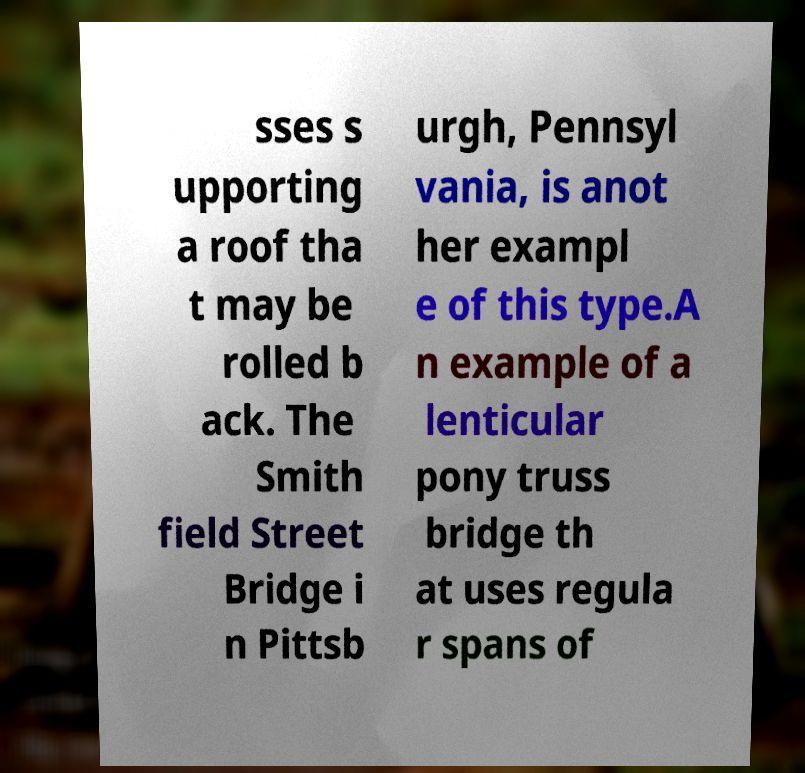Can you read and provide the text displayed in the image?This photo seems to have some interesting text. Can you extract and type it out for me? sses s upporting a roof tha t may be rolled b ack. The Smith field Street Bridge i n Pittsb urgh, Pennsyl vania, is anot her exampl e of this type.A n example of a lenticular pony truss bridge th at uses regula r spans of 